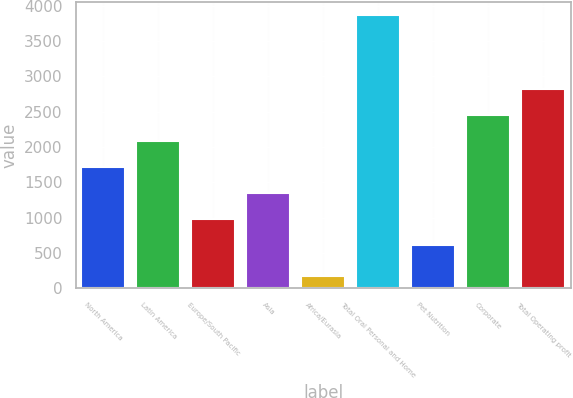Convert chart. <chart><loc_0><loc_0><loc_500><loc_500><bar_chart><fcel>North America<fcel>Latin America<fcel>Europe/South Pacific<fcel>Asia<fcel>Africa/Eurasia<fcel>Total Oral Personal and Home<fcel>Pet Nutrition<fcel>Corporate<fcel>Total Operating profit<nl><fcel>1717.8<fcel>2086.4<fcel>980.6<fcel>1349.2<fcel>178<fcel>3864<fcel>612<fcel>2455<fcel>2823.6<nl></chart> 